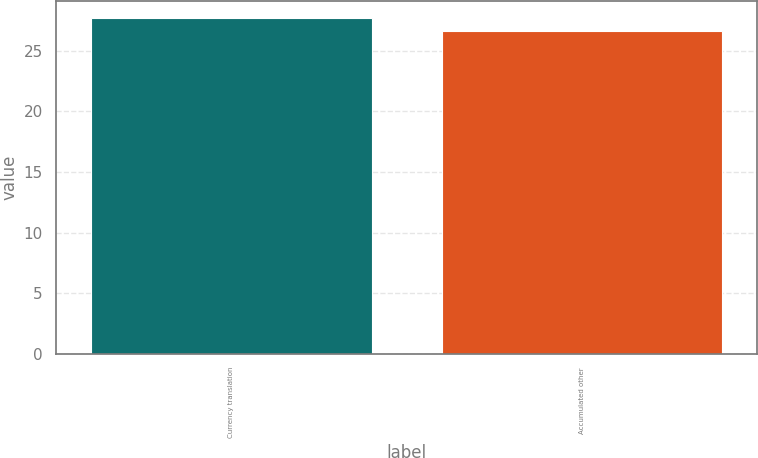Convert chart to OTSL. <chart><loc_0><loc_0><loc_500><loc_500><bar_chart><fcel>Currency translation<fcel>Accumulated other<nl><fcel>27.7<fcel>26.6<nl></chart> 